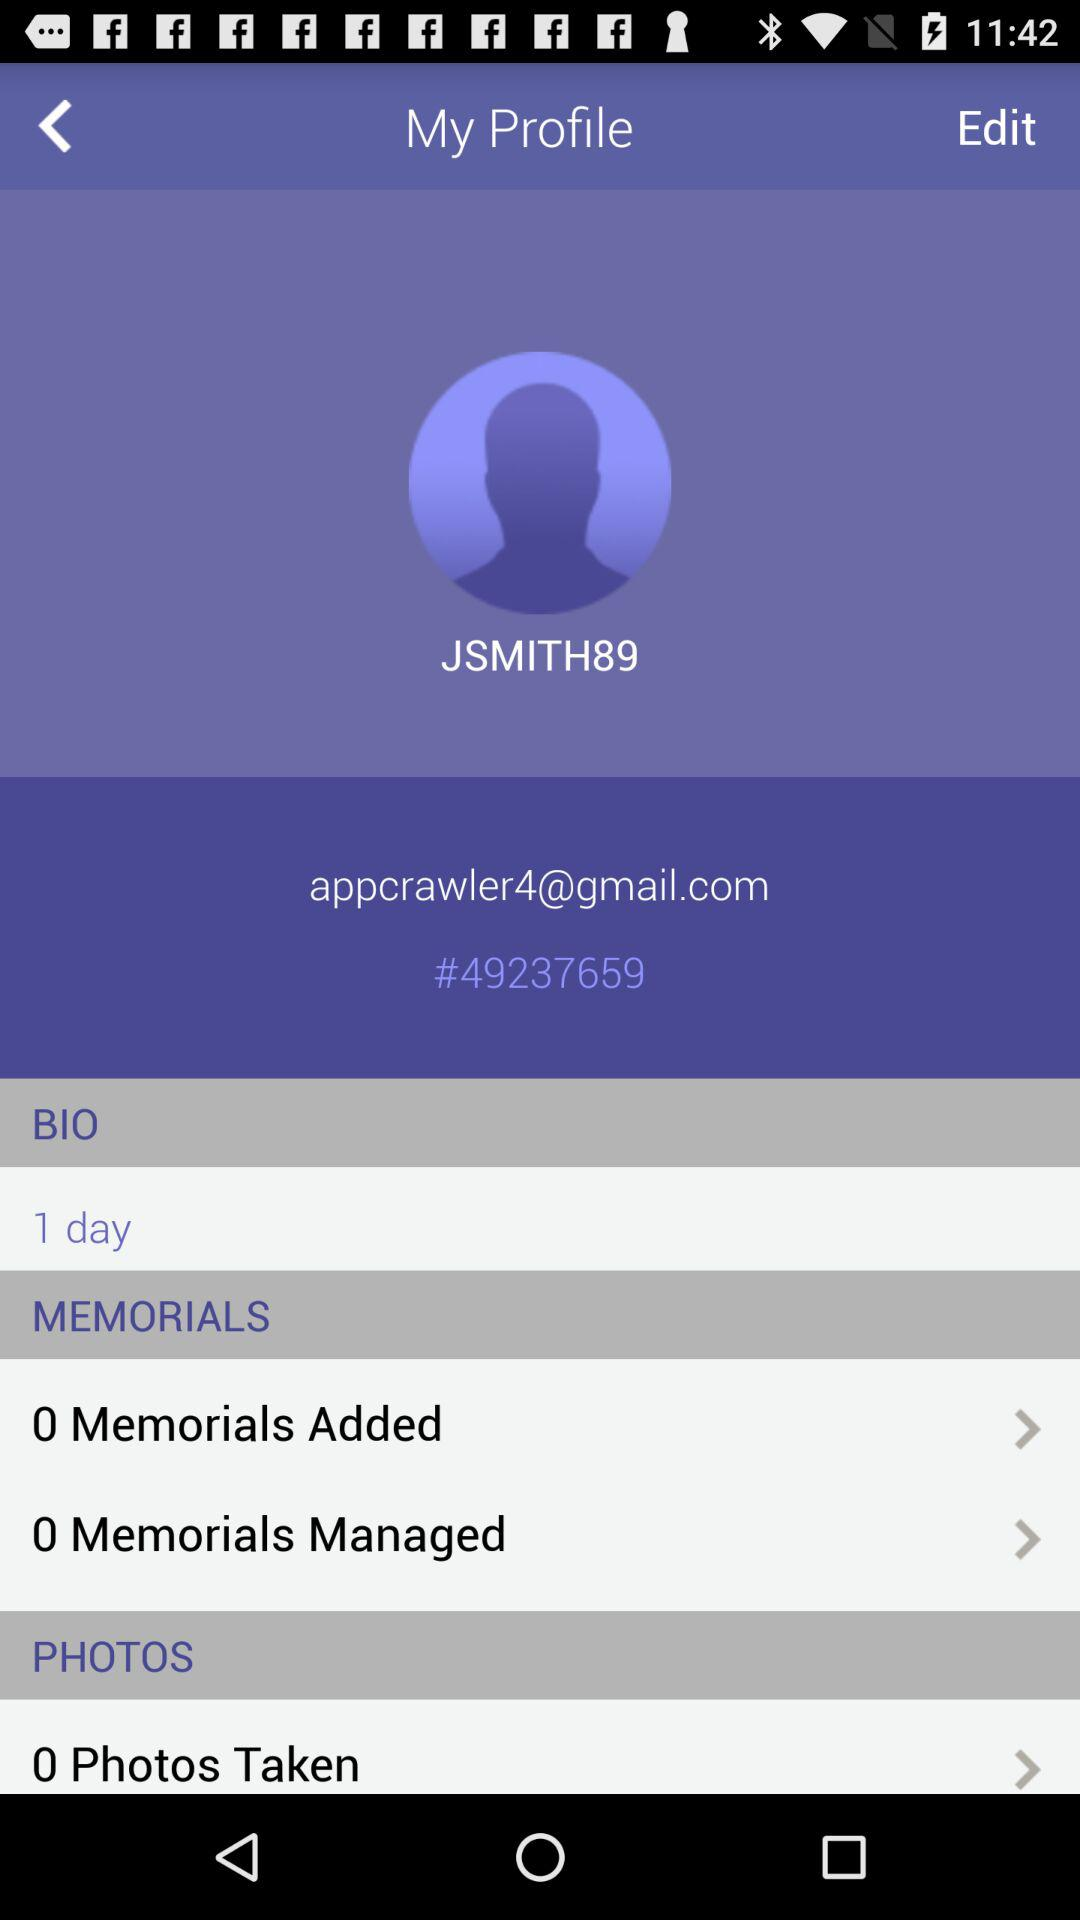How many items are under the Memorials section?
Answer the question using a single word or phrase. 2 